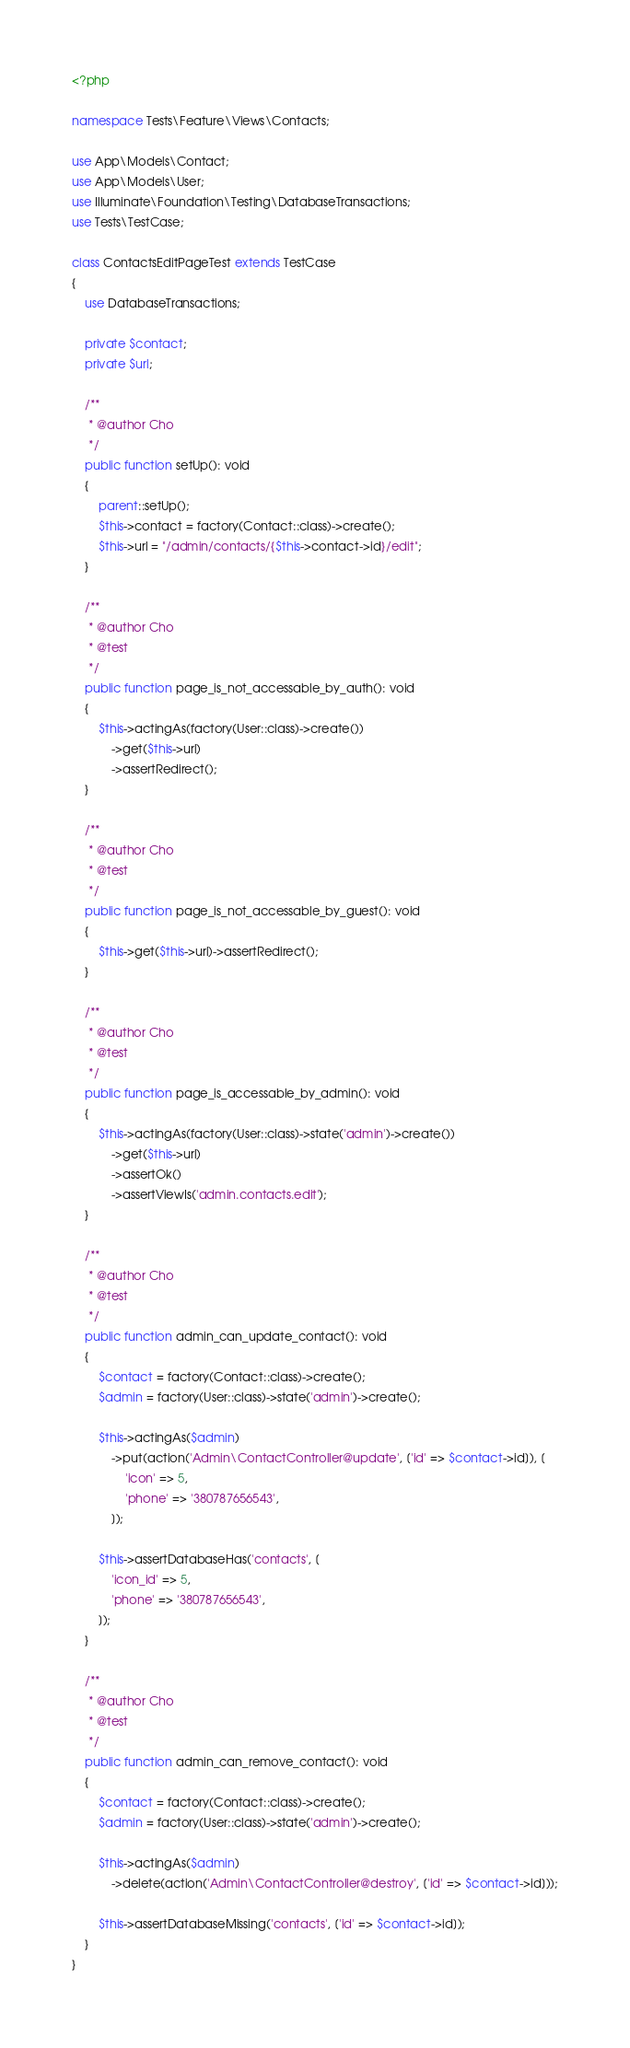<code> <loc_0><loc_0><loc_500><loc_500><_PHP_><?php

namespace Tests\Feature\Views\Contacts;

use App\Models\Contact;
use App\Models\User;
use Illuminate\Foundation\Testing\DatabaseTransactions;
use Tests\TestCase;

class ContactsEditPageTest extends TestCase
{
    use DatabaseTransactions;

    private $contact;
    private $url;

    /**
     * @author Cho
     */
    public function setUp(): void
    {
        parent::setUp();
        $this->contact = factory(Contact::class)->create();
        $this->url = "/admin/contacts/{$this->contact->id}/edit";
    }

    /**
     * @author Cho
     * @test
     */
    public function page_is_not_accessable_by_auth(): void
    {
        $this->actingAs(factory(User::class)->create())
            ->get($this->url)
            ->assertRedirect();
    }

    /**
     * @author Cho
     * @test
     */
    public function page_is_not_accessable_by_guest(): void
    {
        $this->get($this->url)->assertRedirect();
    }

    /**
     * @author Cho
     * @test
     */
    public function page_is_accessable_by_admin(): void
    {
        $this->actingAs(factory(User::class)->state('admin')->create())
            ->get($this->url)
            ->assertOk()
            ->assertViewIs('admin.contacts.edit');
    }

    /**
     * @author Cho
     * @test
     */
    public function admin_can_update_contact(): void
    {
        $contact = factory(Contact::class)->create();
        $admin = factory(User::class)->state('admin')->create();

        $this->actingAs($admin)
            ->put(action('Admin\ContactController@update', ['id' => $contact->id]), [
                'icon' => 5,
                'phone' => '380787656543',
            ]);

        $this->assertDatabaseHas('contacts', [
            'icon_id' => 5,
            'phone' => '380787656543',
        ]);
    }

    /**
     * @author Cho
     * @test
     */
    public function admin_can_remove_contact(): void
    {
        $contact = factory(Contact::class)->create();
        $admin = factory(User::class)->state('admin')->create();

        $this->actingAs($admin)
            ->delete(action('Admin\ContactController@destroy', ['id' => $contact->id]));

        $this->assertDatabaseMissing('contacts', ['id' => $contact->id]);
    }
}
</code> 